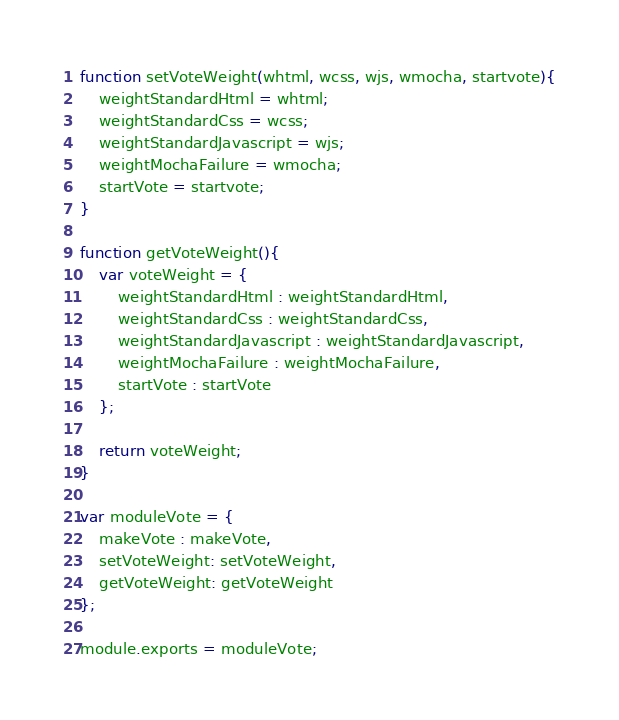Convert code to text. <code><loc_0><loc_0><loc_500><loc_500><_JavaScript_>function setVoteWeight(whtml, wcss, wjs, wmocha, startvote){
    weightStandardHtml = whtml;
    weightStandardCss = wcss;
    weightStandardJavascript = wjs;
    weightMochaFailure = wmocha;
    startVote = startvote;
}

function getVoteWeight(){
    var voteWeight = {
        weightStandardHtml : weightStandardHtml,
        weightStandardCss : weightStandardCss,
        weightStandardJavascript : weightStandardJavascript,
        weightMochaFailure : weightMochaFailure,
        startVote : startVote
    };

    return voteWeight;
}

var moduleVote = {
    makeVote : makeVote,
    setVoteWeight: setVoteWeight,
    getVoteWeight: getVoteWeight
};

module.exports = moduleVote;</code> 